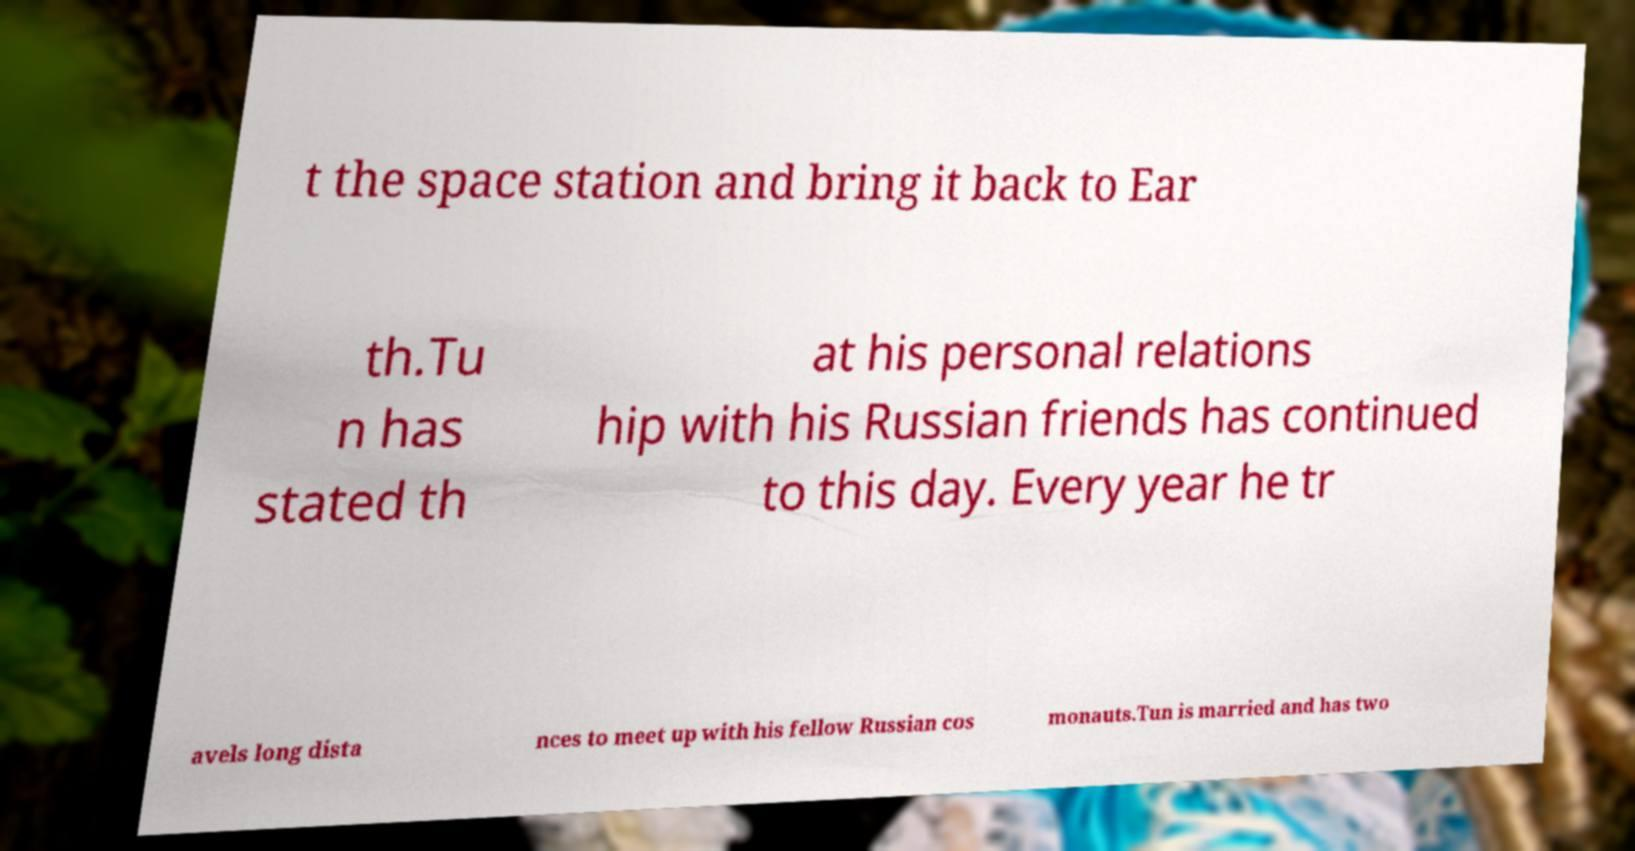Could you extract and type out the text from this image? t the space station and bring it back to Ear th.Tu n has stated th at his personal relations hip with his Russian friends has continued to this day. Every year he tr avels long dista nces to meet up with his fellow Russian cos monauts.Tun is married and has two 